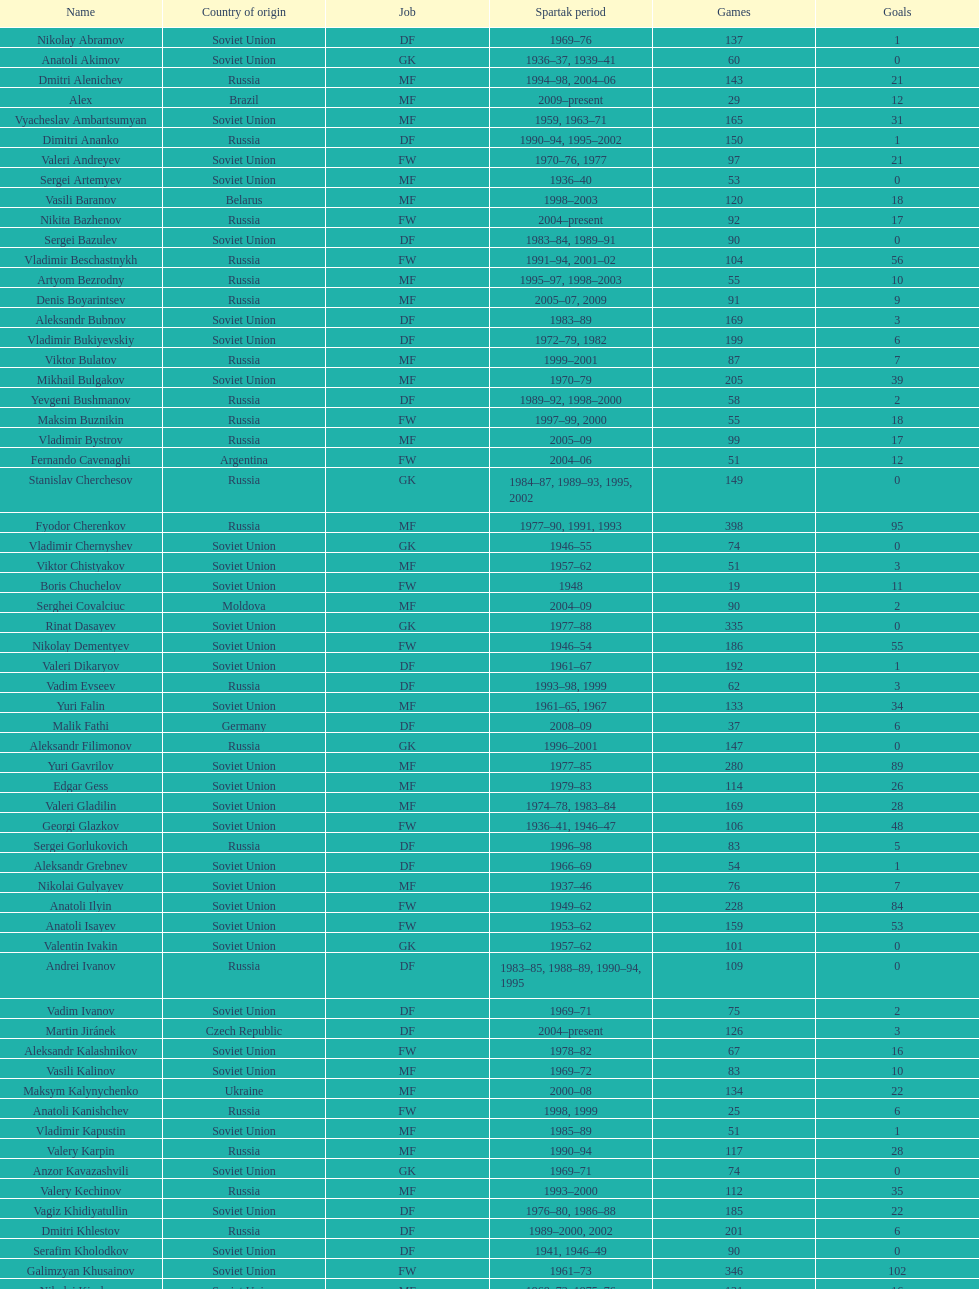Vladimir bukiyevskiy had how many appearances? 199. 